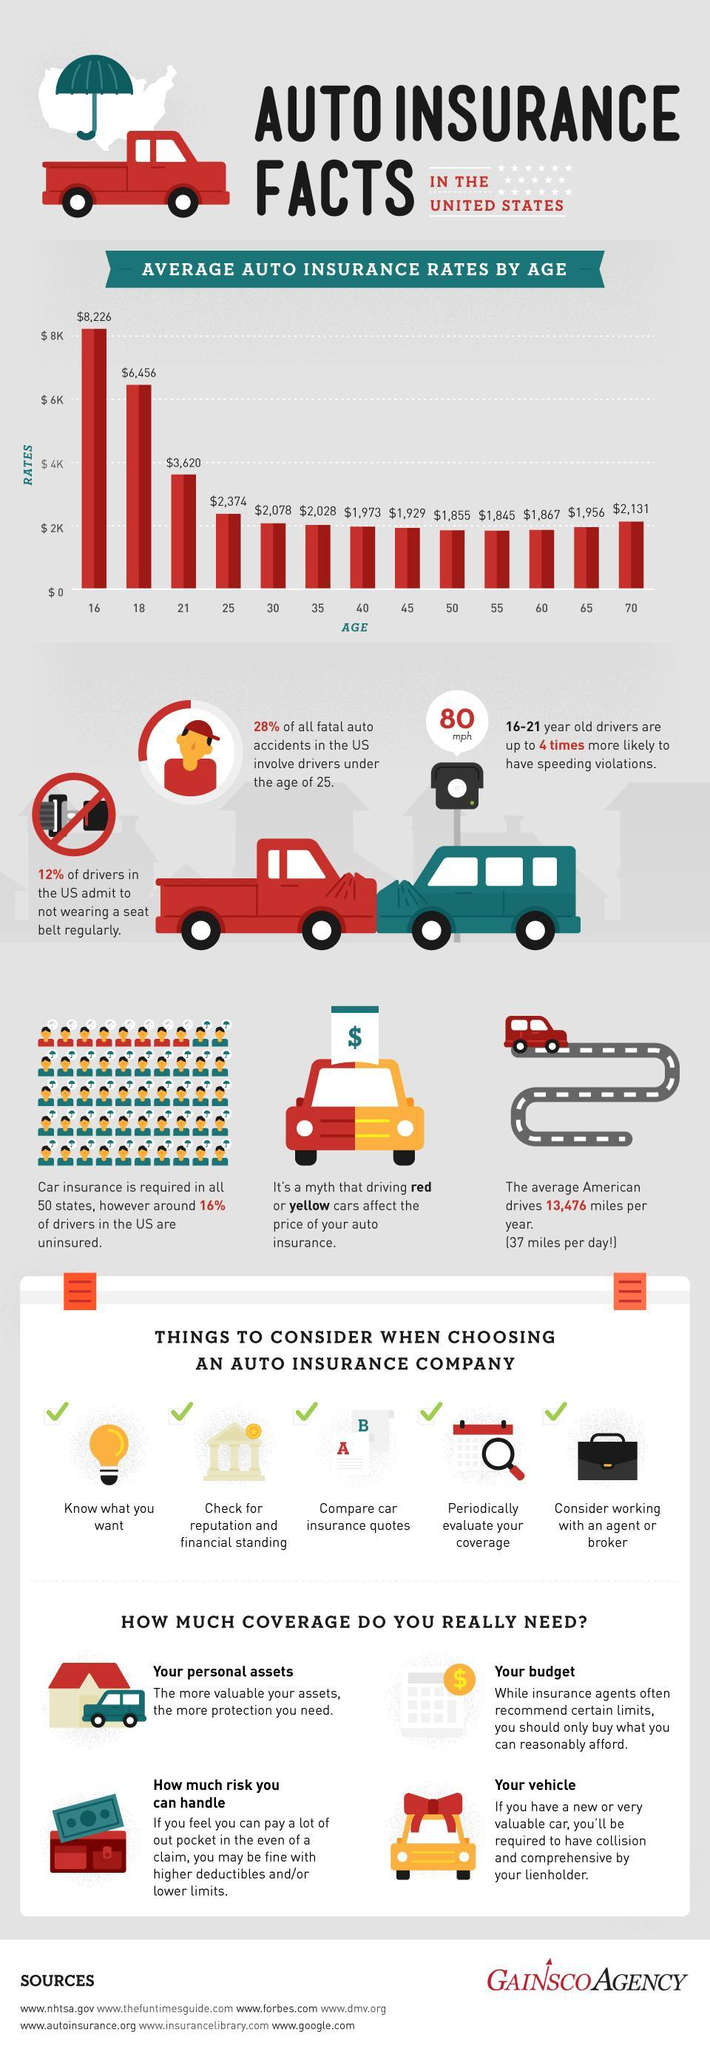What percentage of drivers in the U.S are not insured?
Answer the question with a short phrase. 16% For how many age groups auto insurance rates are above $6k? 2 Drivers belonging to which age group are more involved in auto accidents? drivers under the age of 25 To which age group, the auto insurance rate $6,456 is allowed? 18 How many factors have to be taken care in mind while choosing auto insurance company? 5 To which age group, second least auto insurance rate is allowed? 50 What percentage of drivers in U.S have admitted to wear seat belt ? 88 For how many age groups auto insurance rate is below $2k? 6 